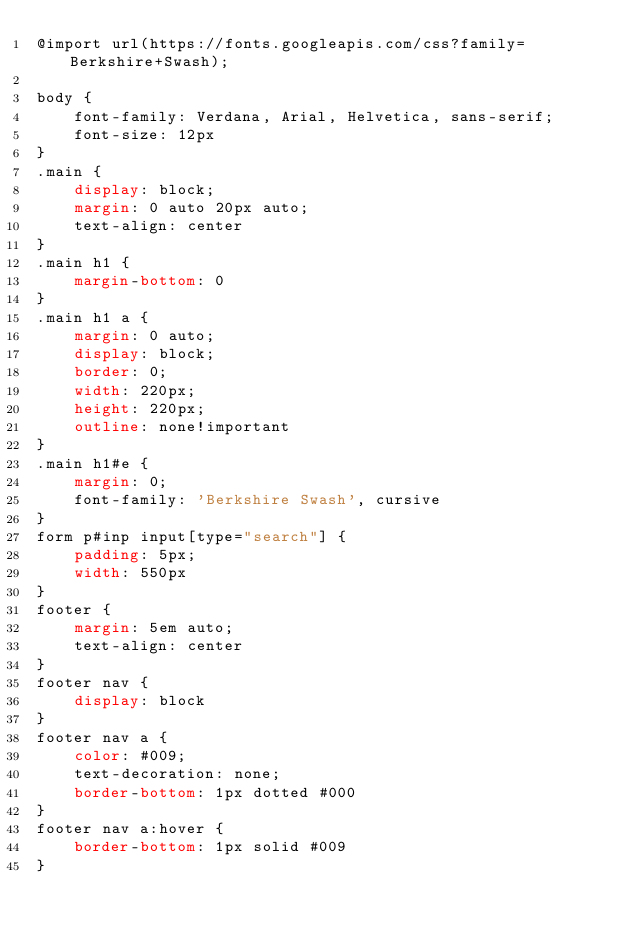Convert code to text. <code><loc_0><loc_0><loc_500><loc_500><_CSS_>@import url(https://fonts.googleapis.com/css?family=Berkshire+Swash);

body {
	font-family: Verdana, Arial, Helvetica, sans-serif;
	font-size: 12px
}
.main {
	display: block;
	margin: 0 auto 20px auto;
	text-align: center
}
.main h1 {
	margin-bottom: 0
}
.main h1 a {
	margin: 0 auto;
	display: block;
	border: 0;
	width: 220px;
	height: 220px;
	outline: none!important
}
.main h1#e {
	margin: 0;
	font-family: 'Berkshire Swash', cursive
}
form p#inp input[type="search"] {
	padding: 5px;
	width: 550px
}
footer {
	margin: 5em auto;
	text-align: center
}
footer nav {
	display: block
}
footer nav a {
	color: #009;
	text-decoration: none;
	border-bottom: 1px dotted #000
}
footer nav a:hover {
	border-bottom: 1px solid #009
}
</code> 